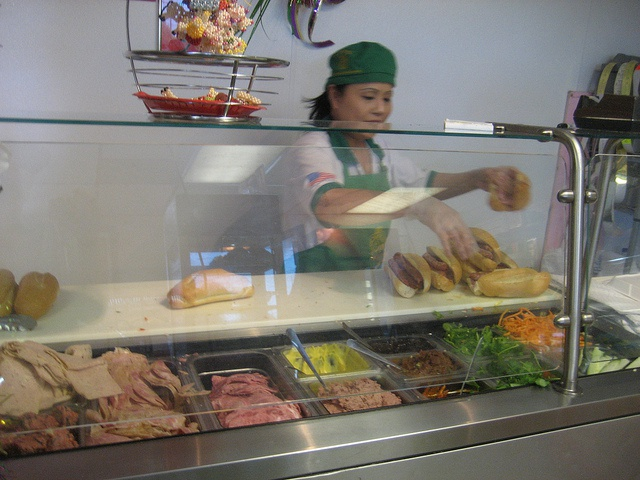Describe the objects in this image and their specific colors. I can see people in darkgray, gray, and black tones, hot dog in darkgray, tan, and lightgray tones, hot dog in darkgray and olive tones, hot dog in darkgray, gray, and maroon tones, and sandwich in darkgray, gray, and maroon tones in this image. 